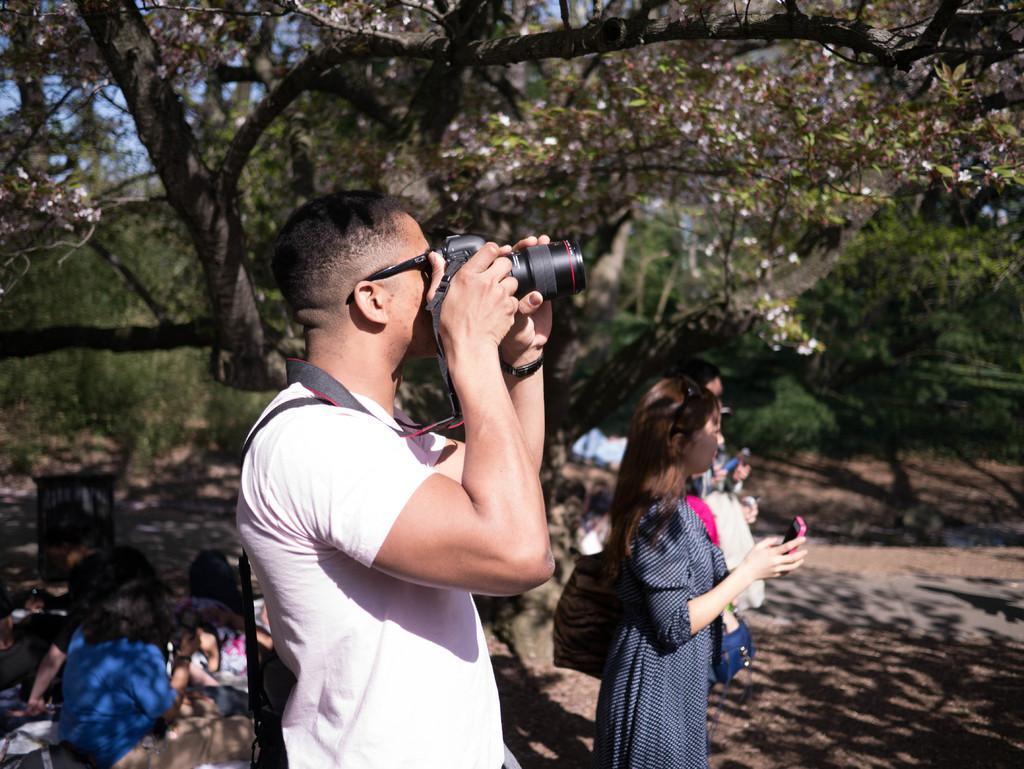In one or two sentences, can you explain what this image depicts? In this image there is a road there are trees and some peoples standing and a man standing and holding a camera and taking pictures and some peoples sitting on the ground. 